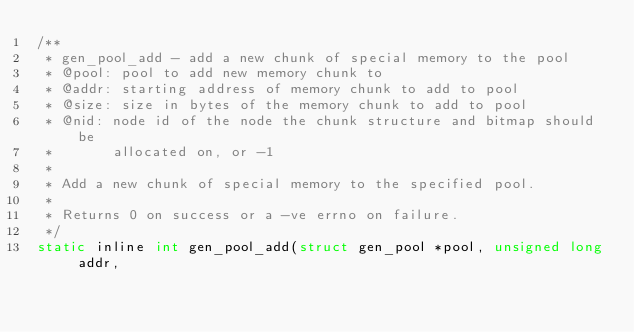<code> <loc_0><loc_0><loc_500><loc_500><_C_>/**
 * gen_pool_add - add a new chunk of special memory to the pool
 * @pool: pool to add new memory chunk to
 * @addr: starting address of memory chunk to add to pool
 * @size: size in bytes of the memory chunk to add to pool
 * @nid: node id of the node the chunk structure and bitmap should be
 *       allocated on, or -1
 *
 * Add a new chunk of special memory to the specified pool.
 *
 * Returns 0 on success or a -ve errno on failure.
 */
static inline int gen_pool_add(struct gen_pool *pool, unsigned long addr,</code> 